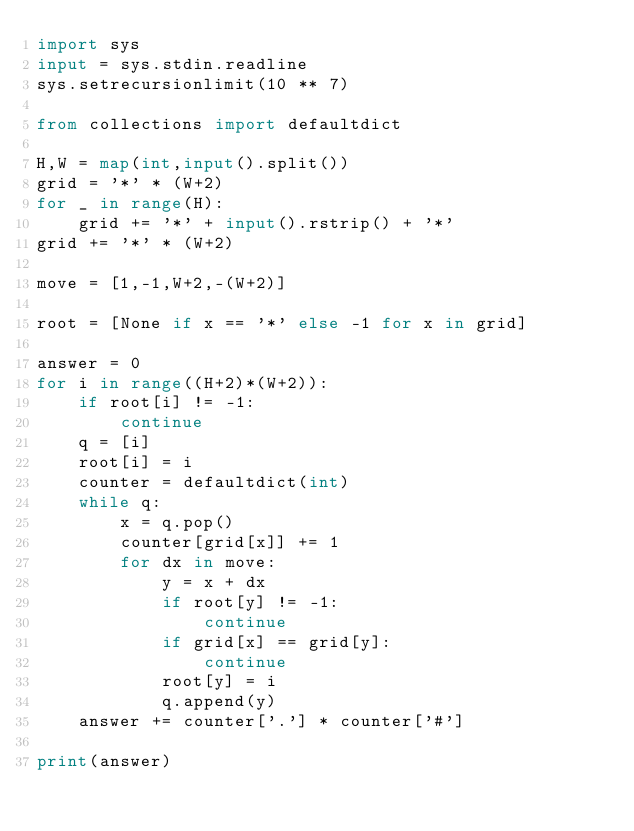Convert code to text. <code><loc_0><loc_0><loc_500><loc_500><_Python_>import sys
input = sys.stdin.readline
sys.setrecursionlimit(10 ** 7)

from collections import defaultdict

H,W = map(int,input().split())
grid = '*' * (W+2)
for _ in range(H):
    grid += '*' + input().rstrip() + '*'
grid += '*' * (W+2)

move = [1,-1,W+2,-(W+2)]

root = [None if x == '*' else -1 for x in grid]

answer = 0
for i in range((H+2)*(W+2)):
    if root[i] != -1:
        continue
    q = [i]
    root[i] = i
    counter = defaultdict(int)
    while q:
        x = q.pop()
        counter[grid[x]] += 1 
        for dx in move:
            y = x + dx
            if root[y] != -1:
                continue
            if grid[x] == grid[y]:
                continue
            root[y] = i
            q.append(y)
    answer += counter['.'] * counter['#']

print(answer)</code> 